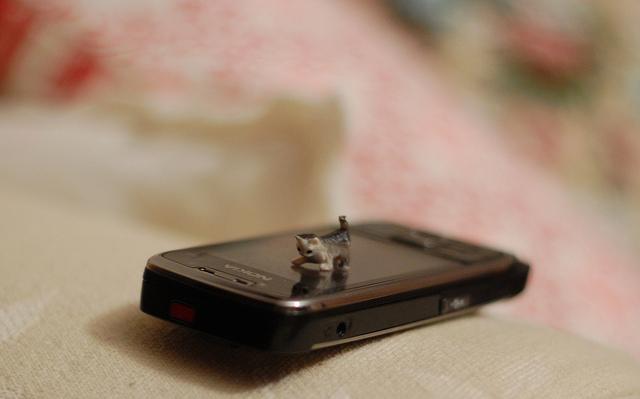Based on the phone size about what size is the cat sculpture?
Choose the right answer from the provided options to respond to the question.
Options: 5 inches, 1/2 inch, 1 foot, 24 inches. 1/2 inch. 